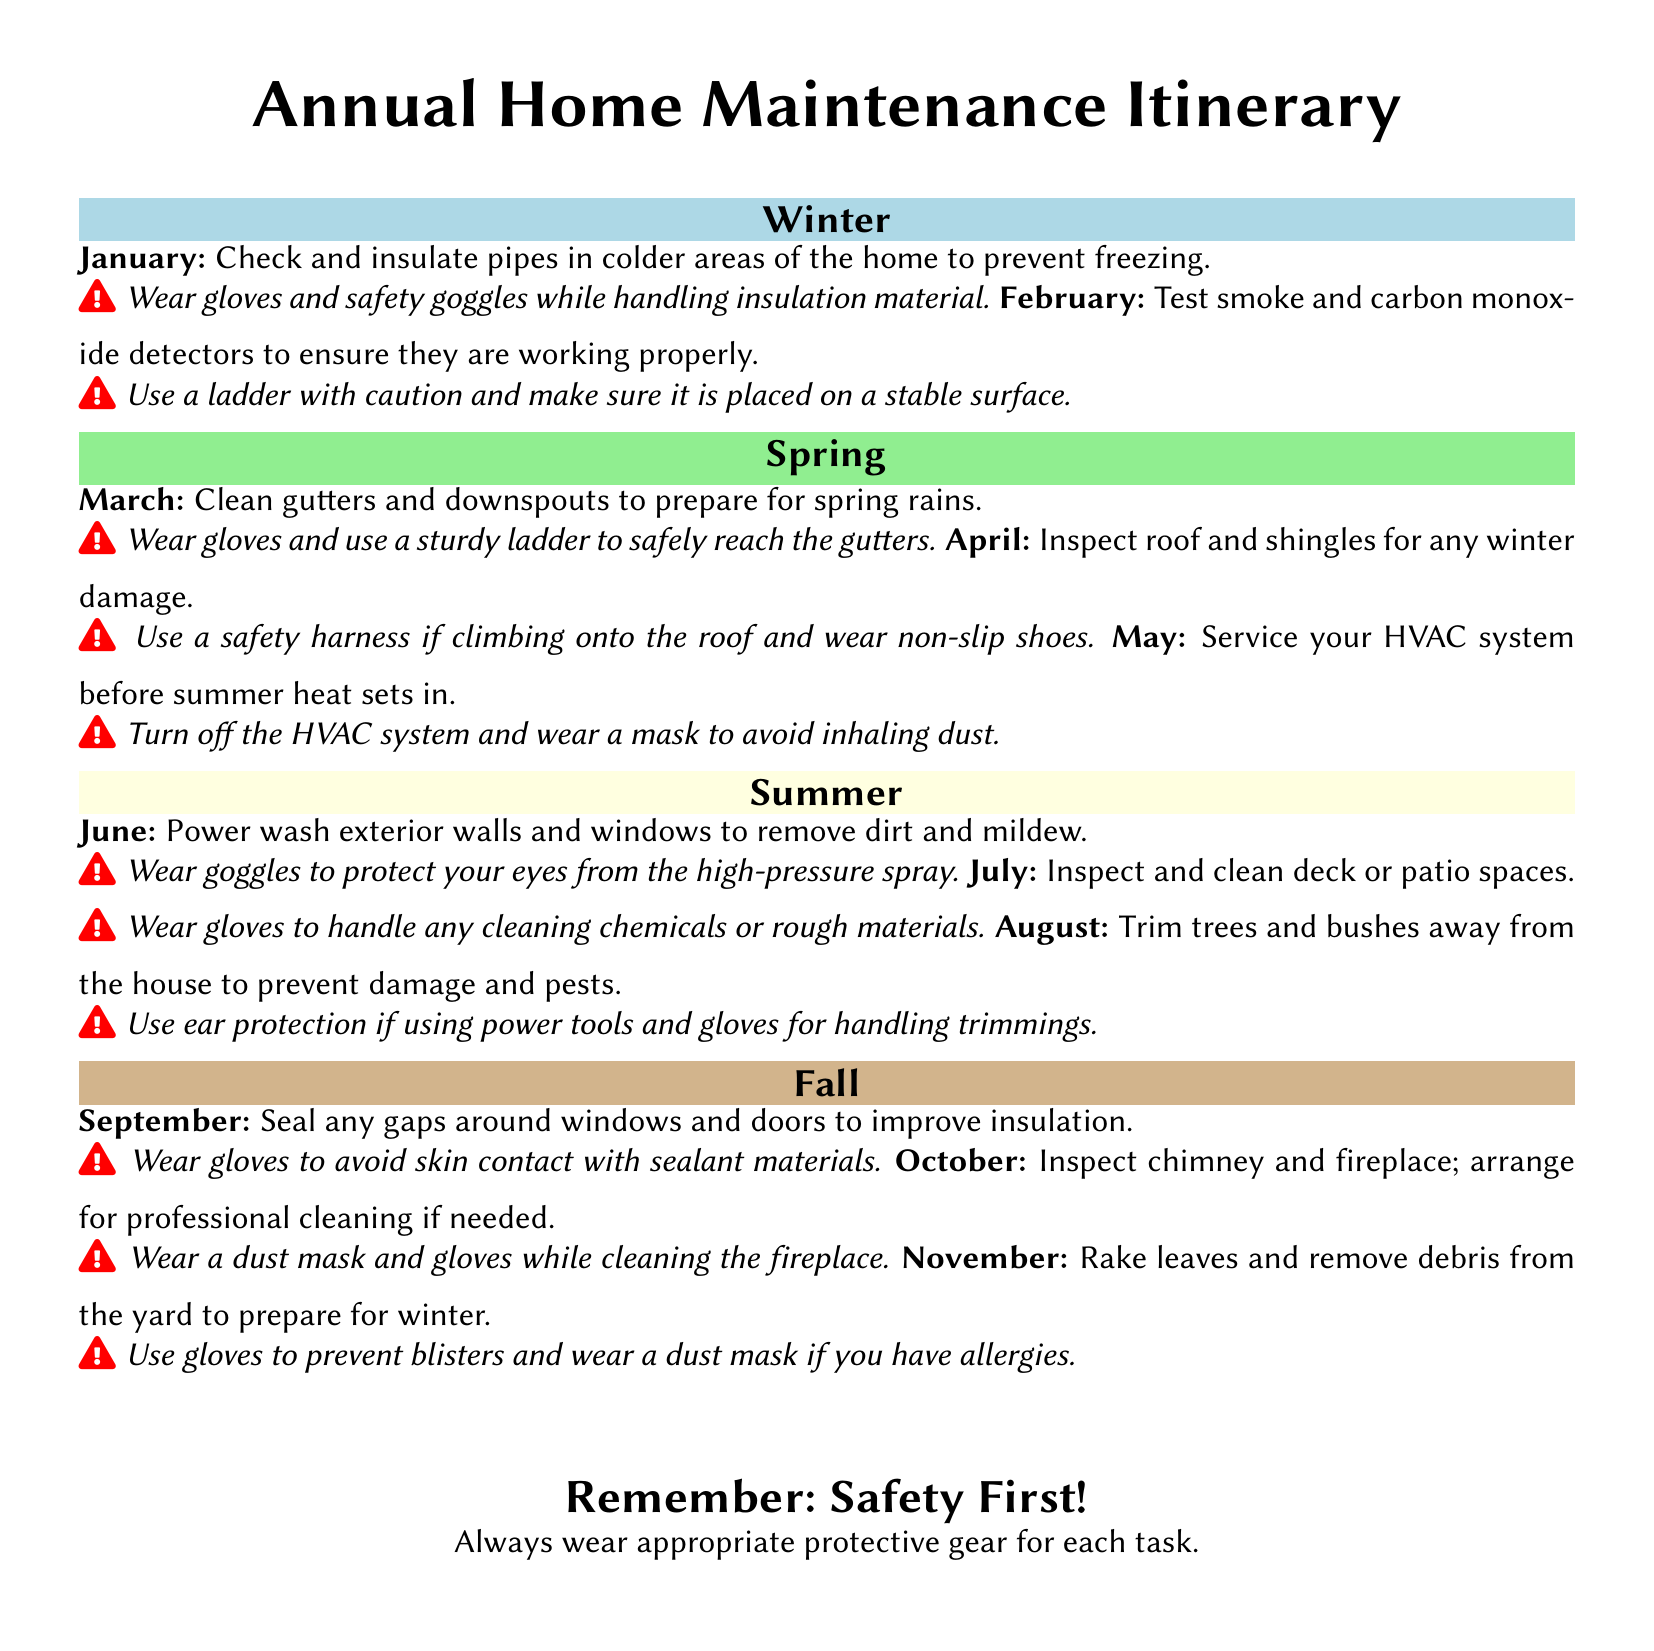What task is recommended for January? The document lists checking and insulating pipes in colder areas of the home to prevent freezing as the task for January.
Answer: Check and insulate pipes in colder areas of the home to prevent freezing What should you wear when inspecting the roof in April? The document advises to wear a safety harness if climbing onto the roof and non-slip shoes for safety while inspecting the roof in April.
Answer: Safety harness and non-slip shoes In which month should you trim trees and bushes? According to the document, trimming trees and bushes is scheduled for August.
Answer: August How many tasks are listed under the fall season? The document contains three tasks listed for the fall season: September, October, and November.
Answer: Three What is the focus of the task in May? The task in May focuses on servicing the HVAC system before the summer heat sets in.
Answer: Service your HVAC system What type of protective gear is mentioned for power washing in June? The document specifies that goggles should be worn to protect your eyes from the high-pressure spray during power washing in June.
Answer: Goggles Which task requires using a dust mask in November? The document states that removing debris from the yard in November requires wearing a dust mask if you have allergies.
Answer: Rake leaves and remove debris from the yard What is the overall advice provided at the end of the document? The document emphasizes the importance of safety first and wearing appropriate protective gear for each task.
Answer: Safety First! 